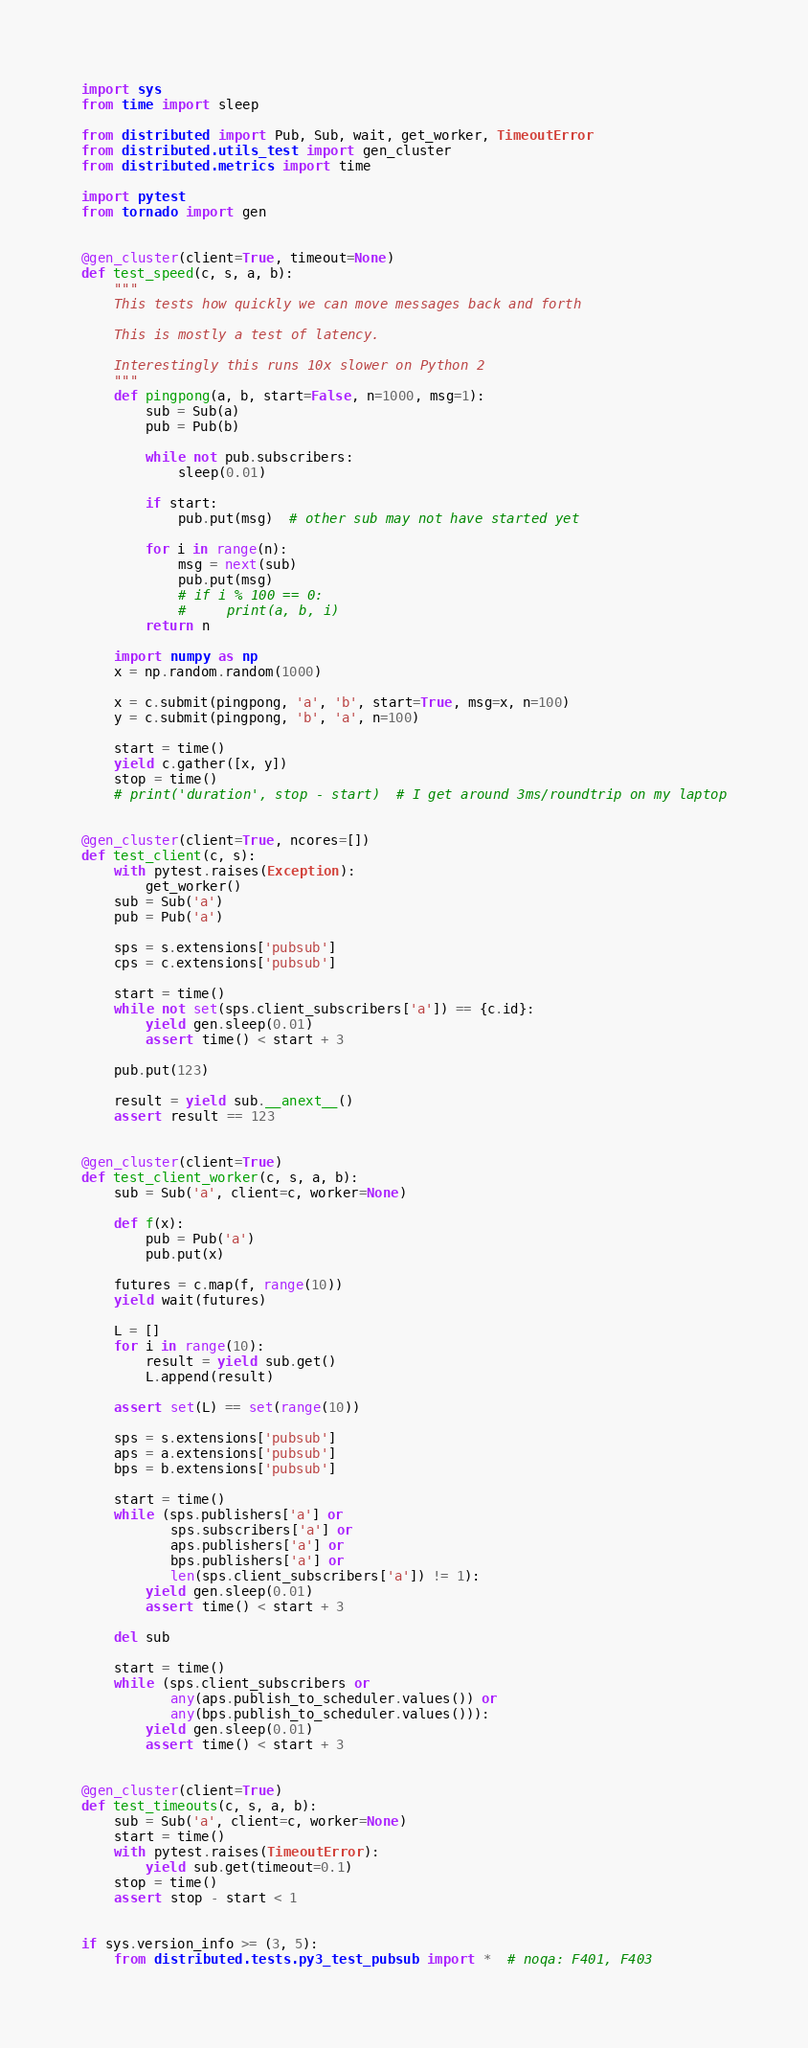Convert code to text. <code><loc_0><loc_0><loc_500><loc_500><_Python_>import sys
from time import sleep

from distributed import Pub, Sub, wait, get_worker, TimeoutError
from distributed.utils_test import gen_cluster
from distributed.metrics import time

import pytest
from tornado import gen


@gen_cluster(client=True, timeout=None)
def test_speed(c, s, a, b):
    """
    This tests how quickly we can move messages back and forth

    This is mostly a test of latency.

    Interestingly this runs 10x slower on Python 2
    """
    def pingpong(a, b, start=False, n=1000, msg=1):
        sub = Sub(a)
        pub = Pub(b)

        while not pub.subscribers:
            sleep(0.01)

        if start:
            pub.put(msg)  # other sub may not have started yet

        for i in range(n):
            msg = next(sub)
            pub.put(msg)
            # if i % 100 == 0:
            #     print(a, b, i)
        return n

    import numpy as np
    x = np.random.random(1000)

    x = c.submit(pingpong, 'a', 'b', start=True, msg=x, n=100)
    y = c.submit(pingpong, 'b', 'a', n=100)

    start = time()
    yield c.gather([x, y])
    stop = time()
    # print('duration', stop - start)  # I get around 3ms/roundtrip on my laptop


@gen_cluster(client=True, ncores=[])
def test_client(c, s):
    with pytest.raises(Exception):
        get_worker()
    sub = Sub('a')
    pub = Pub('a')

    sps = s.extensions['pubsub']
    cps = c.extensions['pubsub']

    start = time()
    while not set(sps.client_subscribers['a']) == {c.id}:
        yield gen.sleep(0.01)
        assert time() < start + 3

    pub.put(123)

    result = yield sub.__anext__()
    assert result == 123


@gen_cluster(client=True)
def test_client_worker(c, s, a, b):
    sub = Sub('a', client=c, worker=None)

    def f(x):
        pub = Pub('a')
        pub.put(x)

    futures = c.map(f, range(10))
    yield wait(futures)

    L = []
    for i in range(10):
        result = yield sub.get()
        L.append(result)

    assert set(L) == set(range(10))

    sps = s.extensions['pubsub']
    aps = a.extensions['pubsub']
    bps = b.extensions['pubsub']

    start = time()
    while (sps.publishers['a'] or
           sps.subscribers['a'] or
           aps.publishers['a'] or
           bps.publishers['a'] or
           len(sps.client_subscribers['a']) != 1):
        yield gen.sleep(0.01)
        assert time() < start + 3

    del sub

    start = time()
    while (sps.client_subscribers or
           any(aps.publish_to_scheduler.values()) or
           any(bps.publish_to_scheduler.values())):
        yield gen.sleep(0.01)
        assert time() < start + 3


@gen_cluster(client=True)
def test_timeouts(c, s, a, b):
    sub = Sub('a', client=c, worker=None)
    start = time()
    with pytest.raises(TimeoutError):
        yield sub.get(timeout=0.1)
    stop = time()
    assert stop - start < 1


if sys.version_info >= (3, 5):
    from distributed.tests.py3_test_pubsub import *  # noqa: F401, F403
</code> 